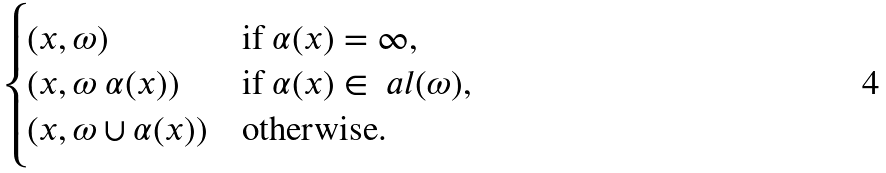<formula> <loc_0><loc_0><loc_500><loc_500>\begin{cases} ( x , \omega ) & \text {if } \alpha ( x ) = \infty , \\ ( x , \omega \ \alpha ( x ) ) & \text {if } \alpha ( x ) \in \ a l ( \omega ) , \\ ( x , \omega \cup \alpha ( x ) ) & \text {otherwise.} \end{cases}</formula> 